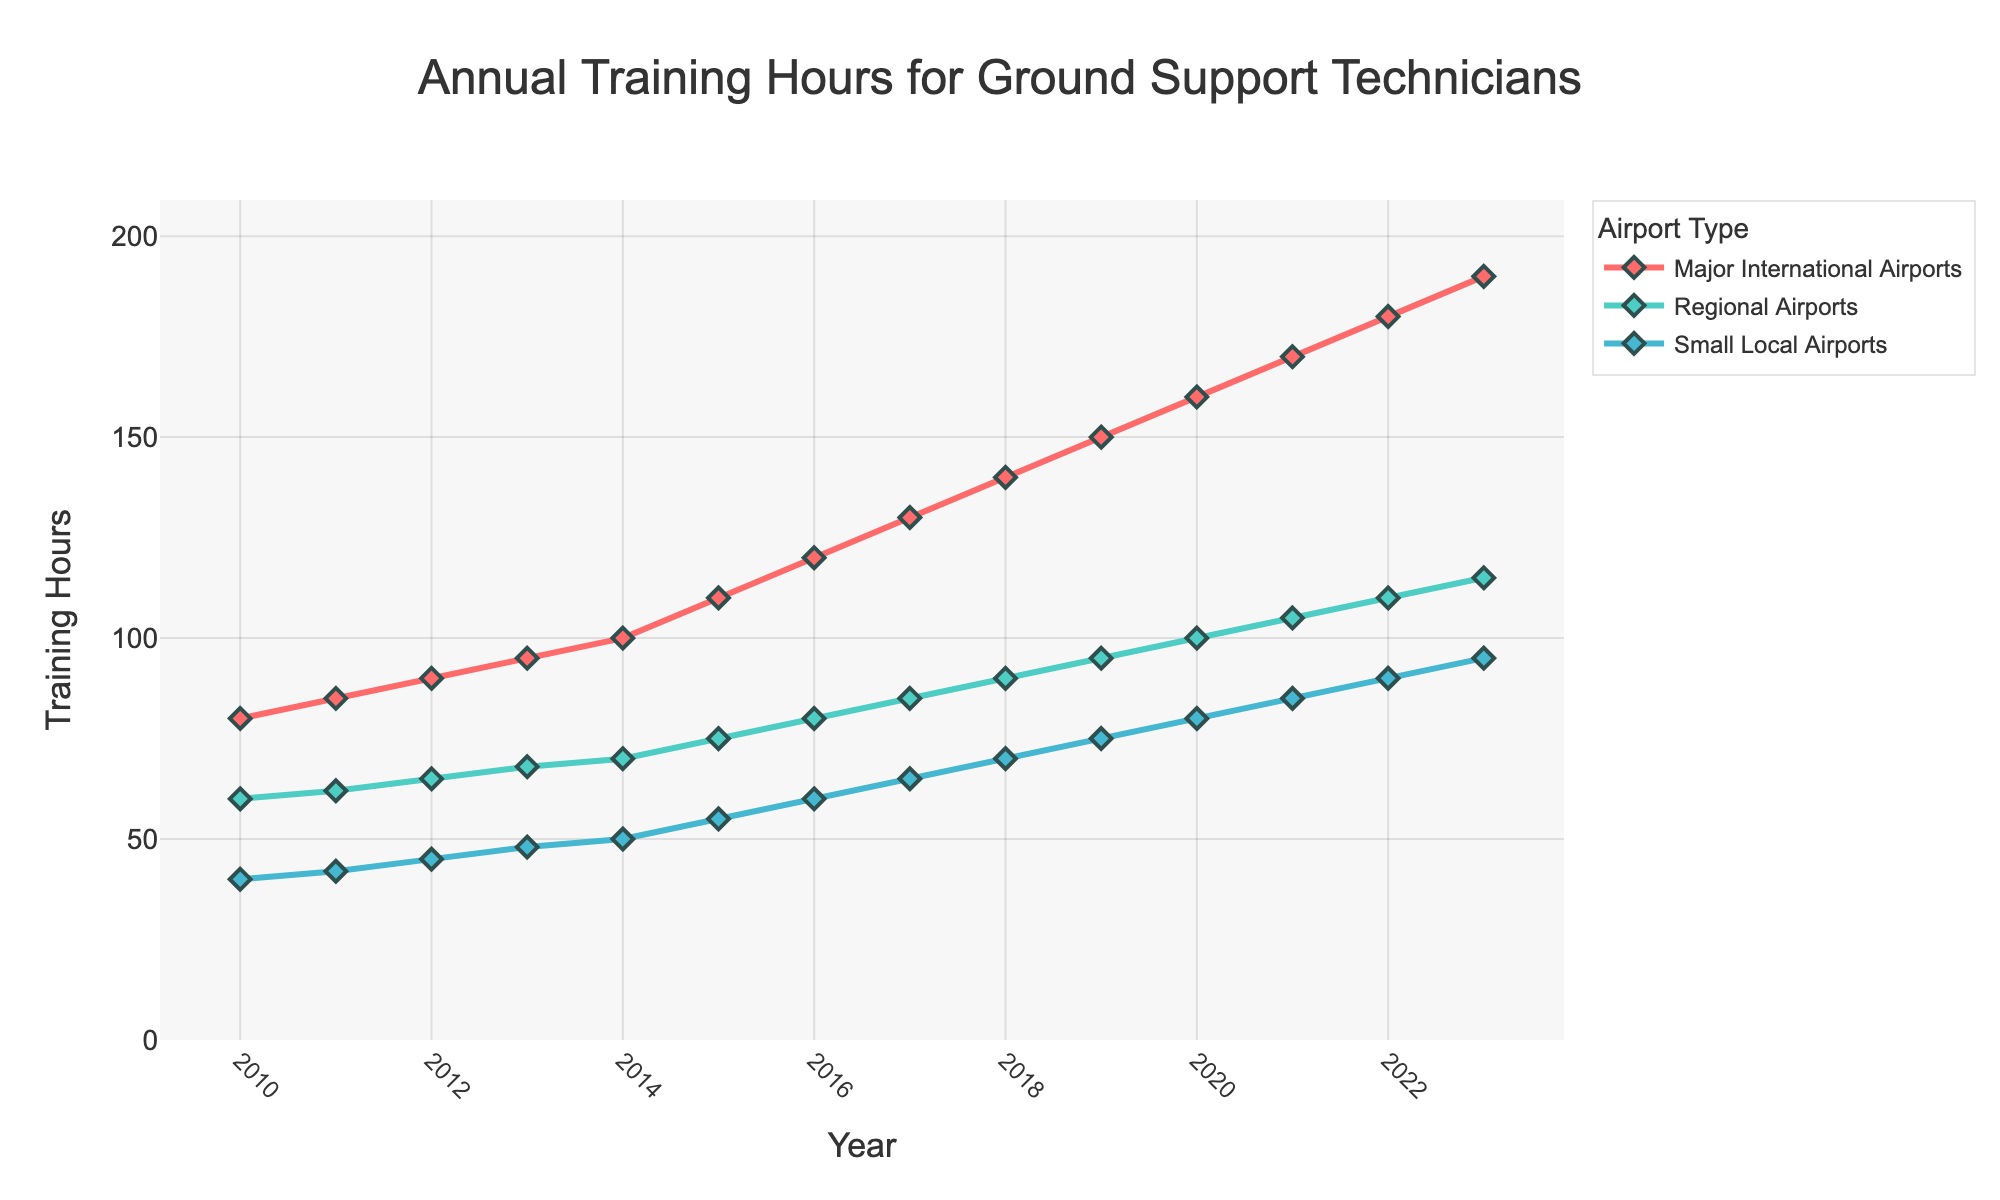How have the annual training hours required for ground support technicians at major international airports changed from 2010 to 2023? The figure shows that the training hours for major international airports have consistently increased from 80 hours in 2010 to 190 hours in 2023.
Answer: Increased from 80 to 190 hours What is the difference in training hours required between major international airports and small local airports in 2020? In 2020, the training hours required for major international airports are 160 hours, and for small local airports, it is 80 hours. The difference is 160 - 80 = 80 hours.
Answer: 80 hours Which airport type has the steepest increase in training hours over the years shown in the figure? By observing the slopes of the lines in the figure, the major international airports have the steepest increase, indicated by the steep rise compared to regional and small local airports.
Answer: Major international airports In which years did the regional airports require exactly 10 hours more training than small local airports? By comparing the data points, regional airports required 10 more hours than small local airports in the years 2014 (70 vs. 60), 2017 (85 vs. 75), and 2020 (100 vs. 90).
Answer: 2014, 2017, 2020 What is the average annual training hours for ground support technicians at small local airports between 2010 and 2023? Average training hours are calculated by summing the yearly values from 2010 to 2023 and dividing by the number of years: (40 + 42 + 45 + 48 + 50 + 55 + 60 + 65 + 70 + 75 + 80 + 85 + 90 + 95) / 14 = 71.4 hours.
Answer: 71.4 hours In which year do major international airports require twice as many training hours as small local airports? In 2022, major international airports require 180 hours, and small local airports require 90 hours. 180 hours is twice 90 hours.
Answer: 2022 How do the training requirements for regional airports in 2018 compare to those for major international airports in 2013? Training hours for regional airports in 2018 are 90 hours, while for major international airports in 2013, it is 95 hours. Regional airports in 2018 require 5 hours less than major international airports in 2013.
Answer: 5 hours less What is the total increase in training hours required for regional airports from 2010 to 2023? The increase in training hours for regional airports from 2010 (60 hours) to 2023 (115 hours) is 115 - 60 = 55 hours.
Answer: 55 hours 